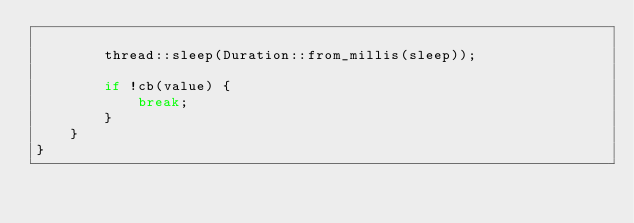<code> <loc_0><loc_0><loc_500><loc_500><_Rust_>
        thread::sleep(Duration::from_millis(sleep));

        if !cb(value) {
            break;
        }
    }
}
</code> 